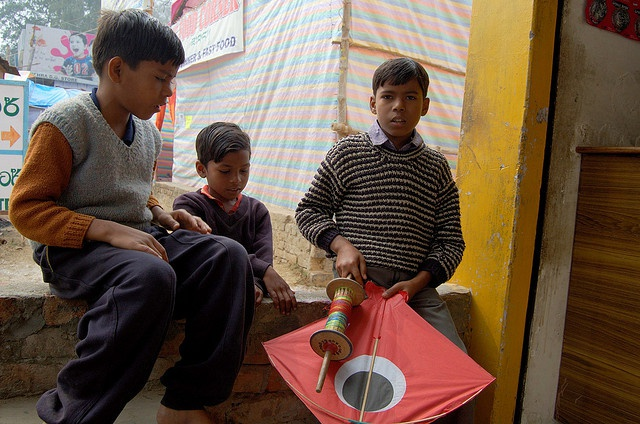Describe the objects in this image and their specific colors. I can see people in darkgray, black, maroon, and gray tones, people in darkgray, black, gray, and maroon tones, kite in darkgray, salmon, brown, and gray tones, and people in darkgray, black, maroon, gray, and brown tones in this image. 